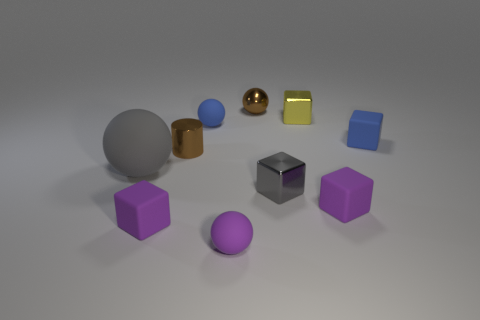Subtract all small gray metallic blocks. How many blocks are left? 4 Subtract 4 balls. How many balls are left? 0 Subtract all blue spheres. How many spheres are left? 3 Subtract all cyan spheres. Subtract all red cylinders. How many spheres are left? 4 Subtract all green spheres. How many yellow cubes are left? 1 Subtract all small blue cubes. Subtract all gray metallic objects. How many objects are left? 8 Add 7 tiny gray objects. How many tiny gray objects are left? 8 Add 3 big gray shiny objects. How many big gray shiny objects exist? 3 Subtract 0 green blocks. How many objects are left? 10 Subtract all spheres. How many objects are left? 6 